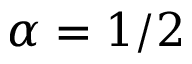<formula> <loc_0><loc_0><loc_500><loc_500>\alpha = 1 / 2</formula> 